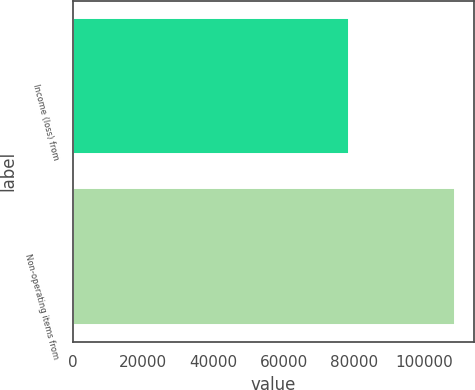Convert chart to OTSL. <chart><loc_0><loc_0><loc_500><loc_500><bar_chart><fcel>Income (loss) from<fcel>Non-operating items from<nl><fcel>78434<fcel>108731<nl></chart> 